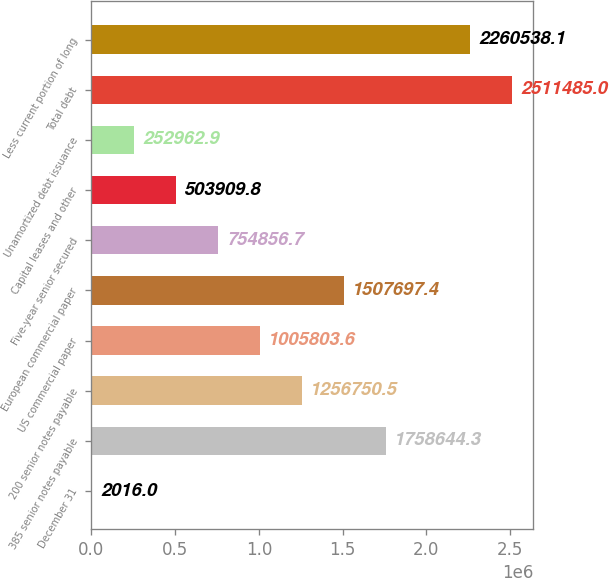Convert chart. <chart><loc_0><loc_0><loc_500><loc_500><bar_chart><fcel>December 31<fcel>385 senior notes payable<fcel>200 senior notes payable<fcel>US commercial paper<fcel>European commercial paper<fcel>Five-year senior secured<fcel>Capital leases and other<fcel>Unamortized debt issuance<fcel>Total debt<fcel>Less current portion of long<nl><fcel>2016<fcel>1.75864e+06<fcel>1.25675e+06<fcel>1.0058e+06<fcel>1.5077e+06<fcel>754857<fcel>503910<fcel>252963<fcel>2.51148e+06<fcel>2.26054e+06<nl></chart> 